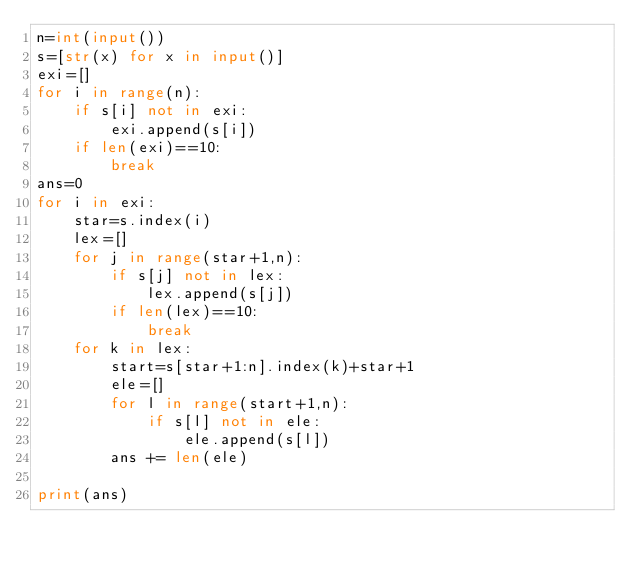<code> <loc_0><loc_0><loc_500><loc_500><_Python_>n=int(input())
s=[str(x) for x in input()]
exi=[]
for i in range(n):
    if s[i] not in exi:
        exi.append(s[i])
    if len(exi)==10:
        break
ans=0
for i in exi:
    star=s.index(i)
    lex=[]
    for j in range(star+1,n):
        if s[j] not in lex:
            lex.append(s[j])
        if len(lex)==10:
            break
    for k in lex:
        start=s[star+1:n].index(k)+star+1
        ele=[]
        for l in range(start+1,n):
            if s[l] not in ele:
                ele.append(s[l])
        ans += len(ele)

print(ans)</code> 